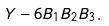Convert formula to latex. <formula><loc_0><loc_0><loc_500><loc_500>Y - 6 B _ { 1 } B _ { 2 } B _ { 3 } .</formula> 